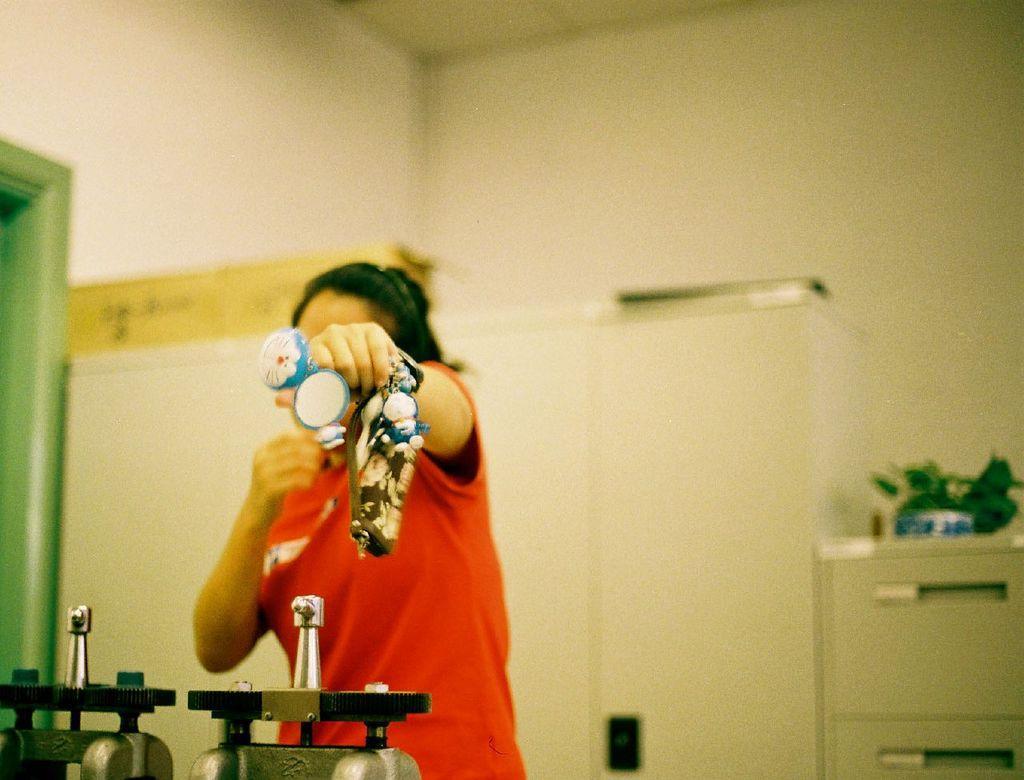Describe this image in one or two sentences. There is a person standing and holding an object,in front of this person we can see equipments. Background we can see wall and object on table. 